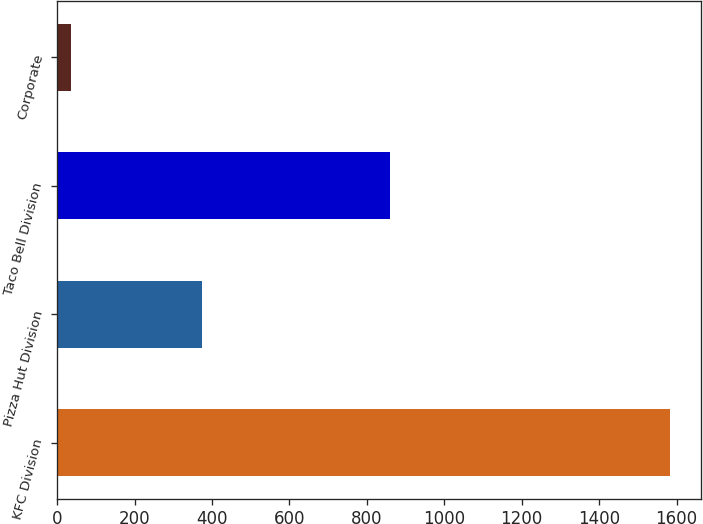<chart> <loc_0><loc_0><loc_500><loc_500><bar_chart><fcel>KFC Division<fcel>Pizza Hut Division<fcel>Taco Bell Division<fcel>Corporate<nl><fcel>1583<fcel>375<fcel>859<fcel>35<nl></chart> 